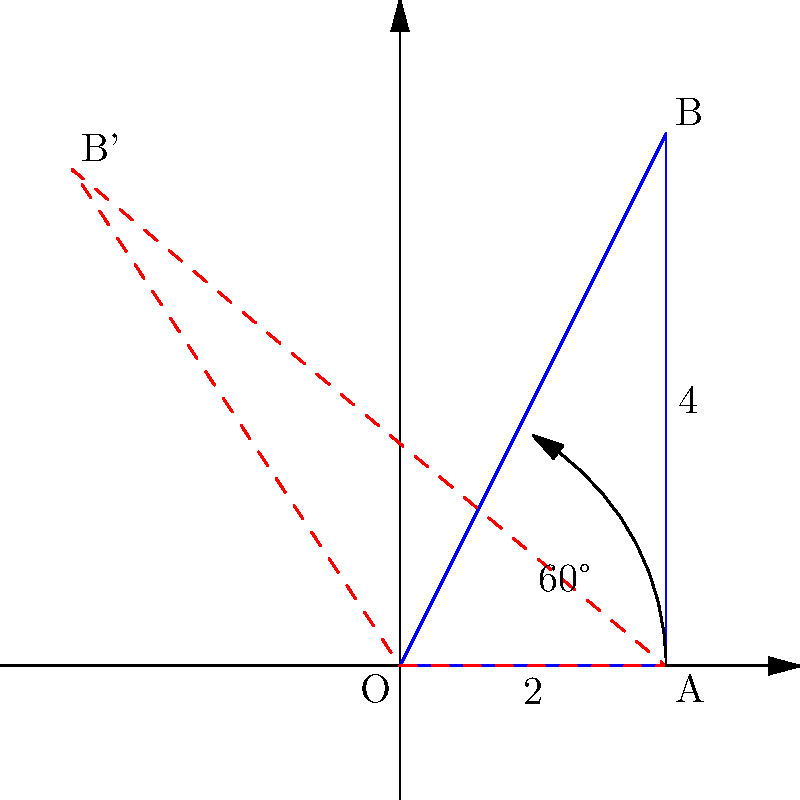In your stationery store, you have a display of a pencil-shaped triangle OAB on a coordinate plane, where O is at the origin (0,0), A is at (2,0), and B is at (2,4). If you rotate this triangle 60° counterclockwise around point O, what are the coordinates of point B after the rotation? To find the coordinates of point B after rotation, we can follow these steps:

1) First, recall the rotation formula for a point (x,y) rotated by an angle θ counterclockwise around the origin:
   x' = x cos θ - y sin θ
   y' = x sin θ + y cos θ

2) In this case, point B has coordinates (2,4), and we're rotating by 60°.

3) Let's calculate the sine and cosine of 60°:
   cos 60° = 1/2
   sin 60° = $\sqrt{3}/2$

4) Now, let's apply the rotation formula:
   x' = 2 * (1/2) - 4 * ($\sqrt{3}/2$) = 1 - 2$\sqrt{3}$
   y' = 2 * ($\sqrt{3}/2$) + 4 * (1/2) = $\sqrt{3}$ + 2

5) Therefore, after rotation, the coordinates of B' are (1 - 2$\sqrt{3}$, $\sqrt{3}$ + 2).

6) We can simplify this slightly:
   x' = 1 - 2$\sqrt{3}$ ≈ -2.46
   y' = $\sqrt{3}$ + 2 ≈ 3.73
Answer: (1 - 2$\sqrt{3}$, $\sqrt{3}$ + 2) 